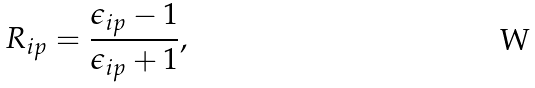<formula> <loc_0><loc_0><loc_500><loc_500>R _ { i p } = \frac { \epsilon _ { i p } - 1 } { \epsilon _ { i p } + 1 } ,</formula> 